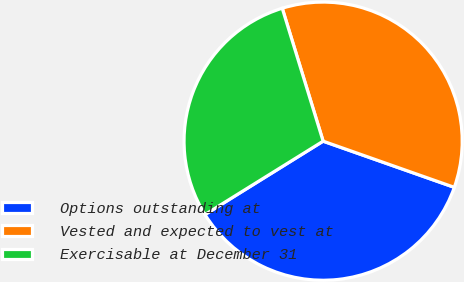Convert chart. <chart><loc_0><loc_0><loc_500><loc_500><pie_chart><fcel>Options outstanding at<fcel>Vested and expected to vest at<fcel>Exercisable at December 31<nl><fcel>35.77%<fcel>35.14%<fcel>29.1%<nl></chart> 